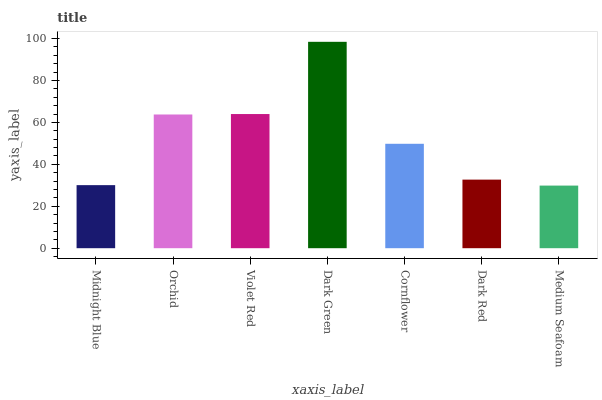Is Orchid the minimum?
Answer yes or no. No. Is Orchid the maximum?
Answer yes or no. No. Is Orchid greater than Midnight Blue?
Answer yes or no. Yes. Is Midnight Blue less than Orchid?
Answer yes or no. Yes. Is Midnight Blue greater than Orchid?
Answer yes or no. No. Is Orchid less than Midnight Blue?
Answer yes or no. No. Is Cornflower the high median?
Answer yes or no. Yes. Is Cornflower the low median?
Answer yes or no. Yes. Is Violet Red the high median?
Answer yes or no. No. Is Orchid the low median?
Answer yes or no. No. 